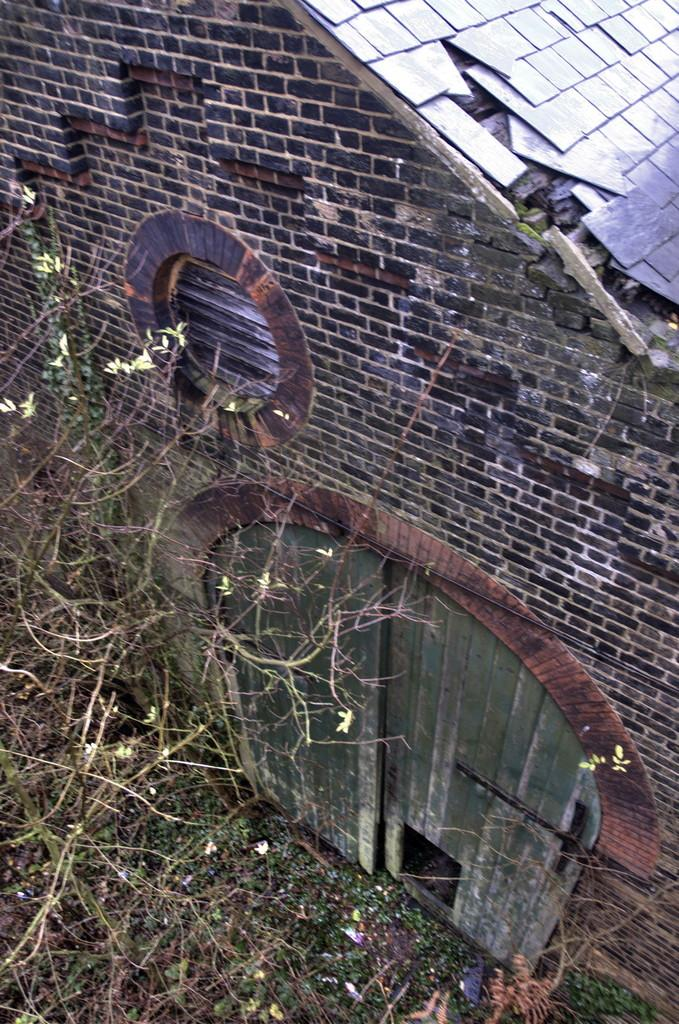What type of structure is in the image? There is an old building in the image. What material is used for the door of the building? The building has a wooden door. What can be seen in front of the building? There are trees in front of the building. Is the building sinking into quicksand in the image? No, there is no quicksand present in the image, and the building appears to be standing on solid ground. 